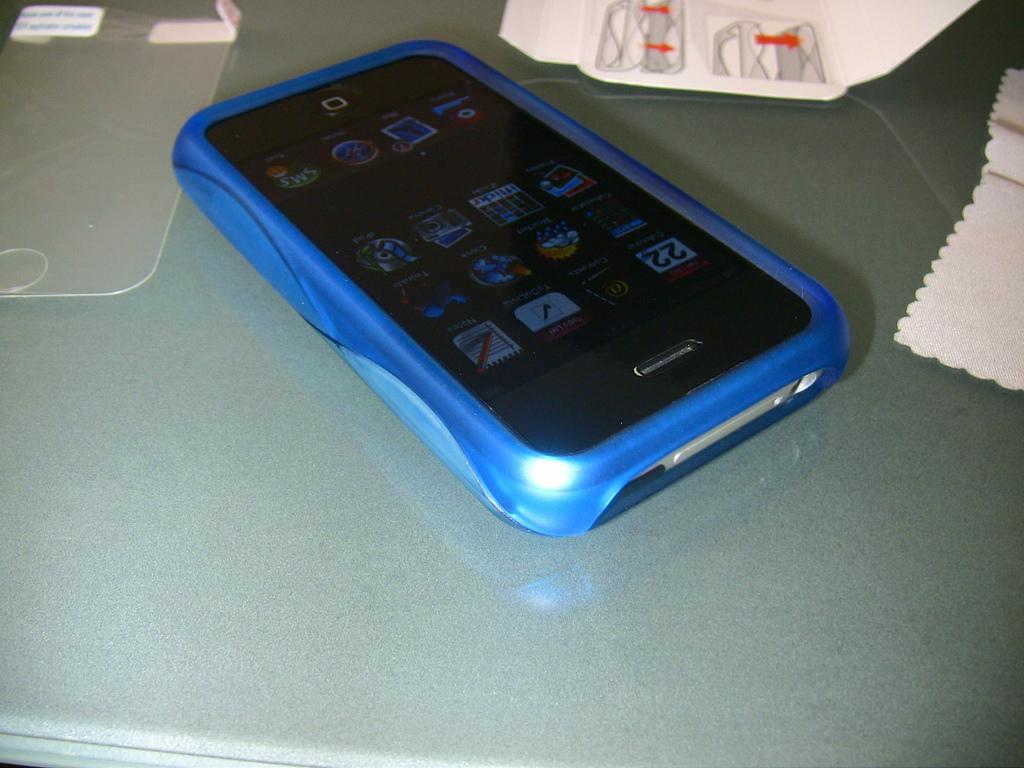What type of material is the object made of in the image? There is tempered glass in the image. What electronic device is present in the image? There is a mobile phone in the image. What type of paper-based items can be seen in the image? There are papers in the image. What color is the surface on which the objects are placed? The objects are on a white surface. Can you see a guitar being played in the image? There is no guitar present in the image. Is there a pickle on the white surface in the image? There is no pickle present in the image. 